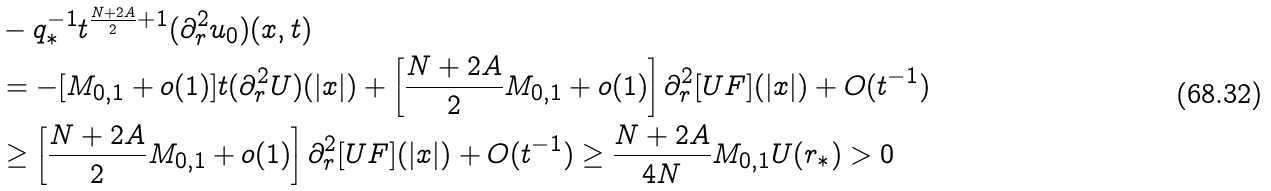Convert formula to latex. <formula><loc_0><loc_0><loc_500><loc_500>& - q _ { * } ^ { - 1 } t ^ { \frac { N + 2 A } { 2 } + 1 } ( \partial _ { r } ^ { 2 } u _ { 0 } ) ( x , t ) \\ & = - [ M _ { 0 , 1 } + o ( 1 ) ] t ( \partial _ { r } ^ { 2 } U ) ( | x | ) + \left [ \frac { N + 2 A } { 2 } M _ { 0 , 1 } + o ( 1 ) \right ] \partial _ { r } ^ { 2 } [ U F ] ( | x | ) + O ( t ^ { - 1 } ) \\ & \geq \left [ \frac { N + 2 A } { 2 } M _ { 0 , 1 } + o ( 1 ) \right ] \partial _ { r } ^ { 2 } [ U F ] ( | x | ) + O ( t ^ { - 1 } ) \geq \frac { N + 2 A } { 4 N } M _ { 0 , 1 } U ( r _ { * } ) > 0</formula> 